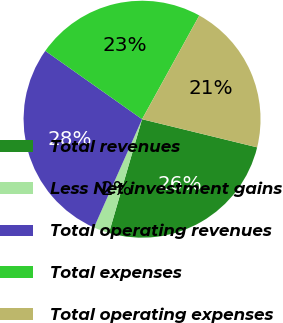Convert chart. <chart><loc_0><loc_0><loc_500><loc_500><pie_chart><fcel>Total revenues<fcel>Less Net investment gains<fcel>Total operating revenues<fcel>Total expenses<fcel>Total operating expenses<nl><fcel>25.69%<fcel>2.14%<fcel>28.14%<fcel>23.24%<fcel>20.79%<nl></chart> 